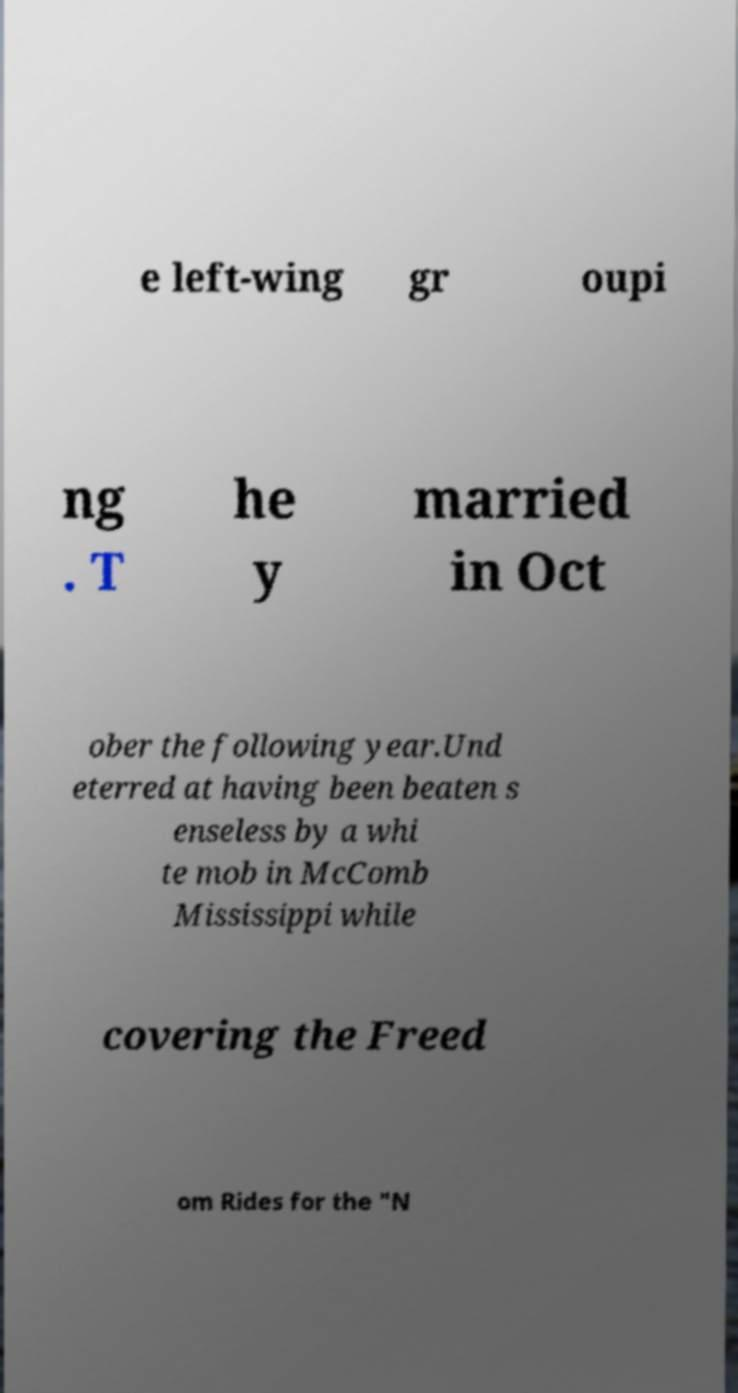What messages or text are displayed in this image? I need them in a readable, typed format. e left-wing gr oupi ng . T he y married in Oct ober the following year.Und eterred at having been beaten s enseless by a whi te mob in McComb Mississippi while covering the Freed om Rides for the "N 